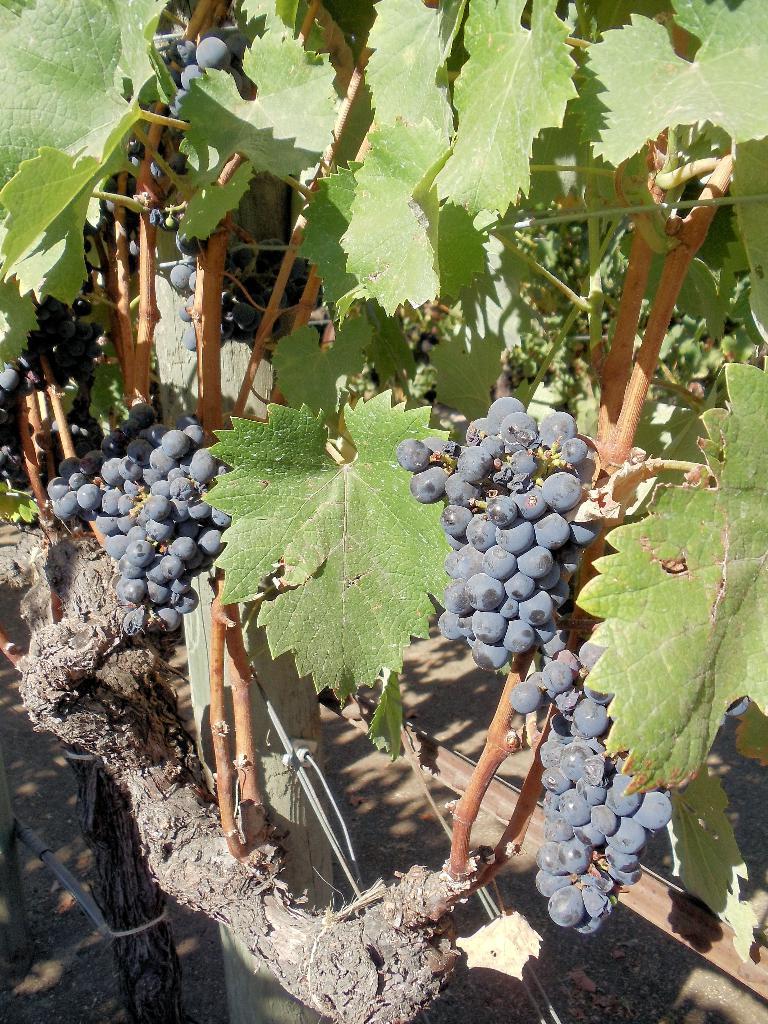In one or two sentences, can you explain what this image depicts? In the image I can see a plant to which there are some grape fruits and leaves. 